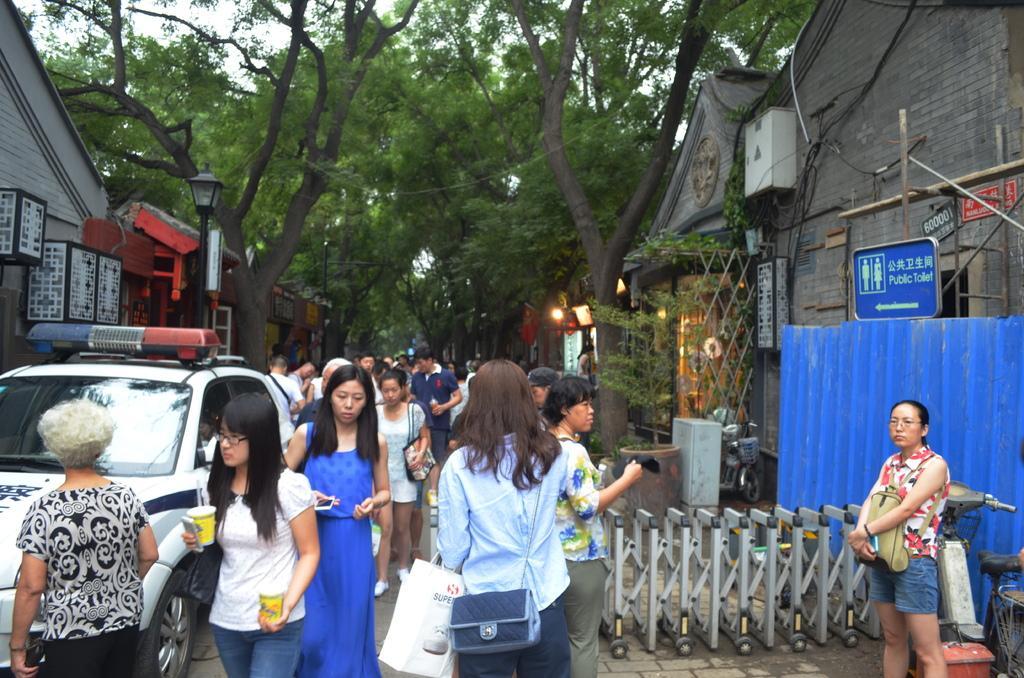Could you give a brief overview of what you see in this image? In this picture, I can see a group of people, Who are holding a bags, and holding an object, mobiles and i can see a cop vehicle which is parked towards a left side, few trees, light, and a public toilet board and a street. 